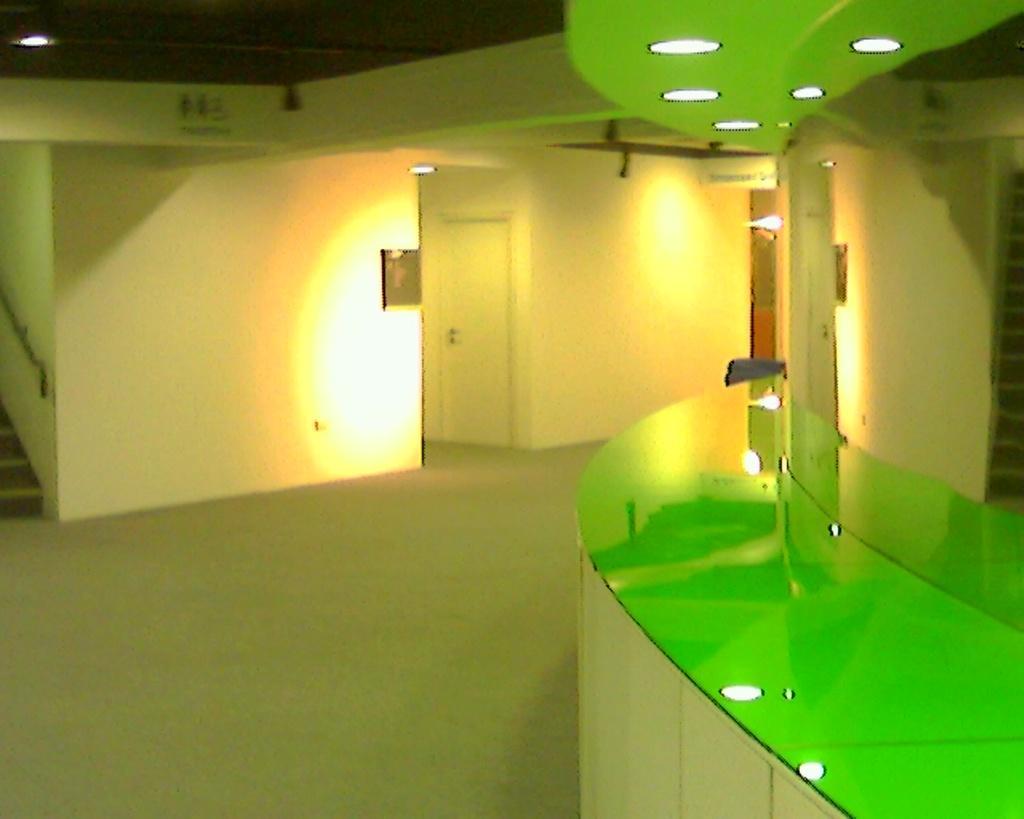Could you give a brief overview of what you see in this image? In this image, I can see the inside view of a building. On the right side of the image, there are ceiling lights, which are attached to the ceiling. On the left corner of the image, these are the stairs. At the center of the image, I can see a door. 